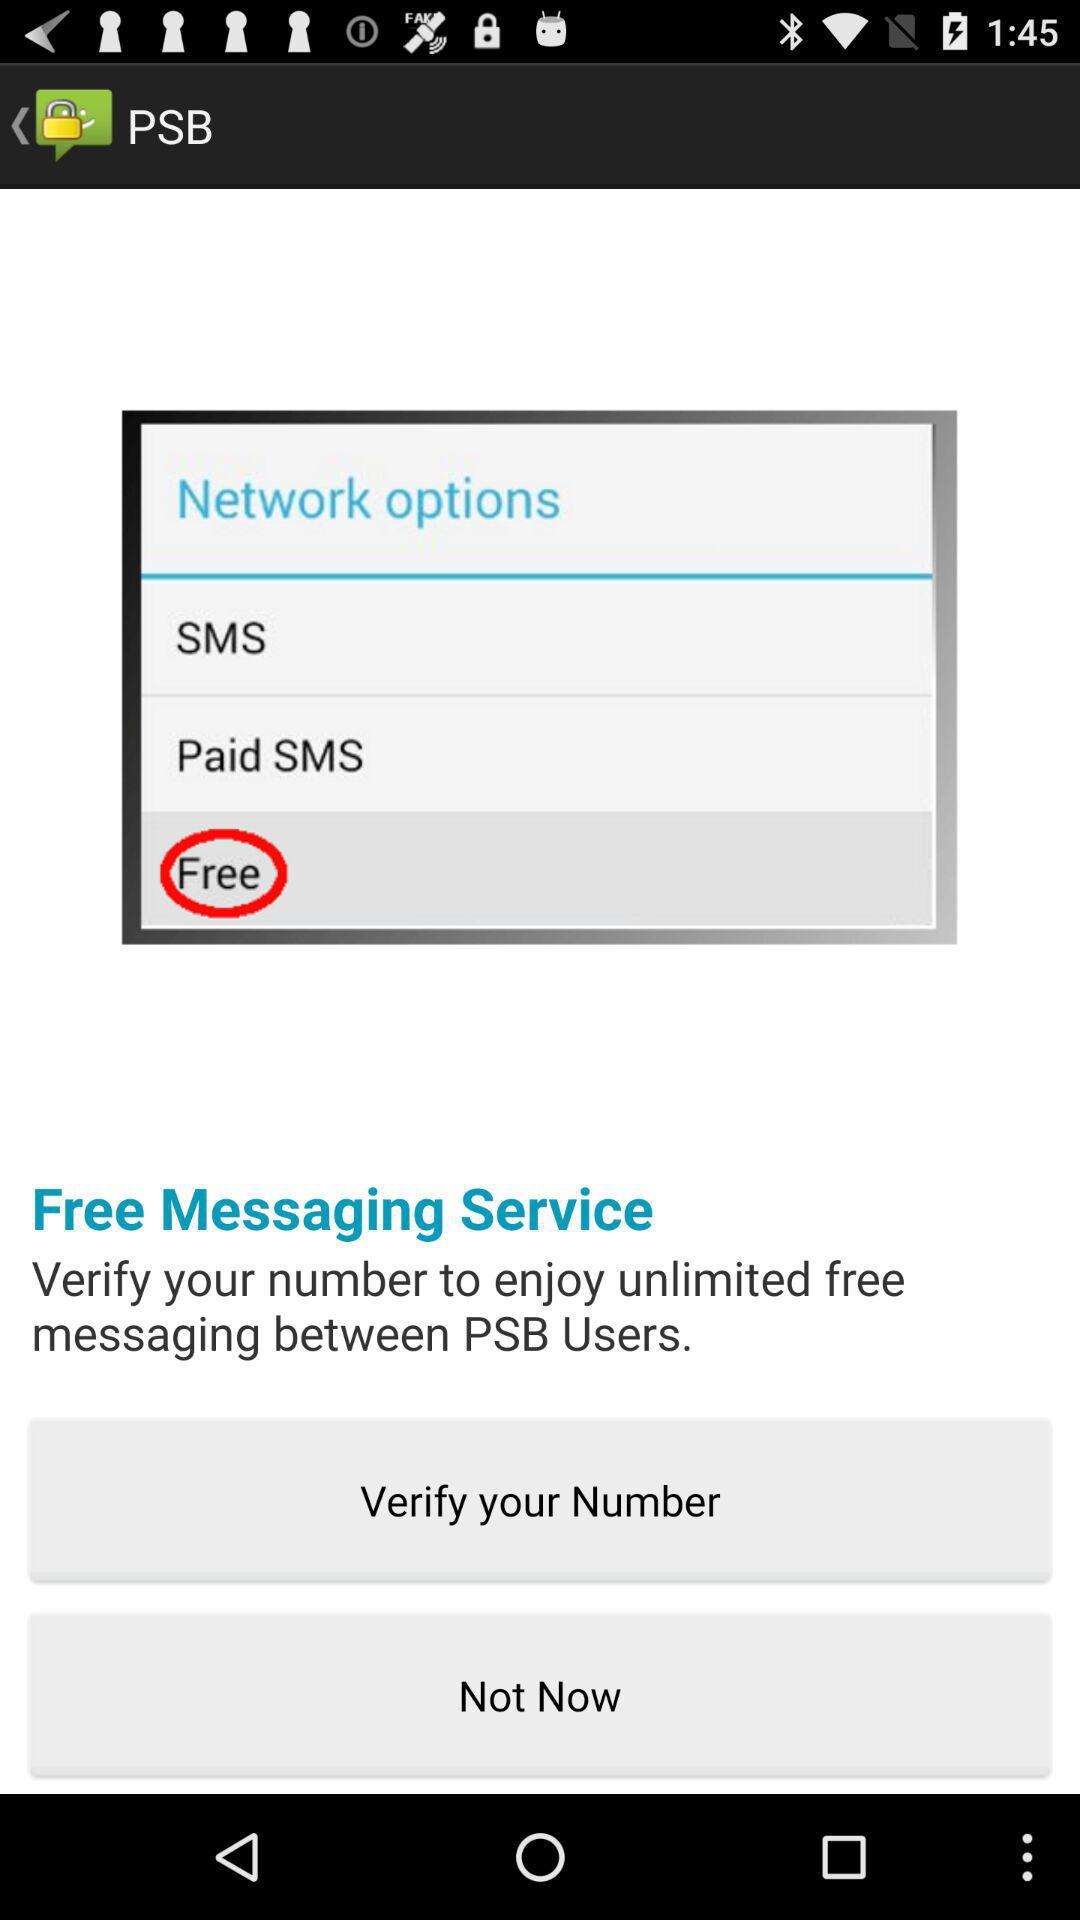How many options are there to send a message?
Answer the question using a single word or phrase. 3 